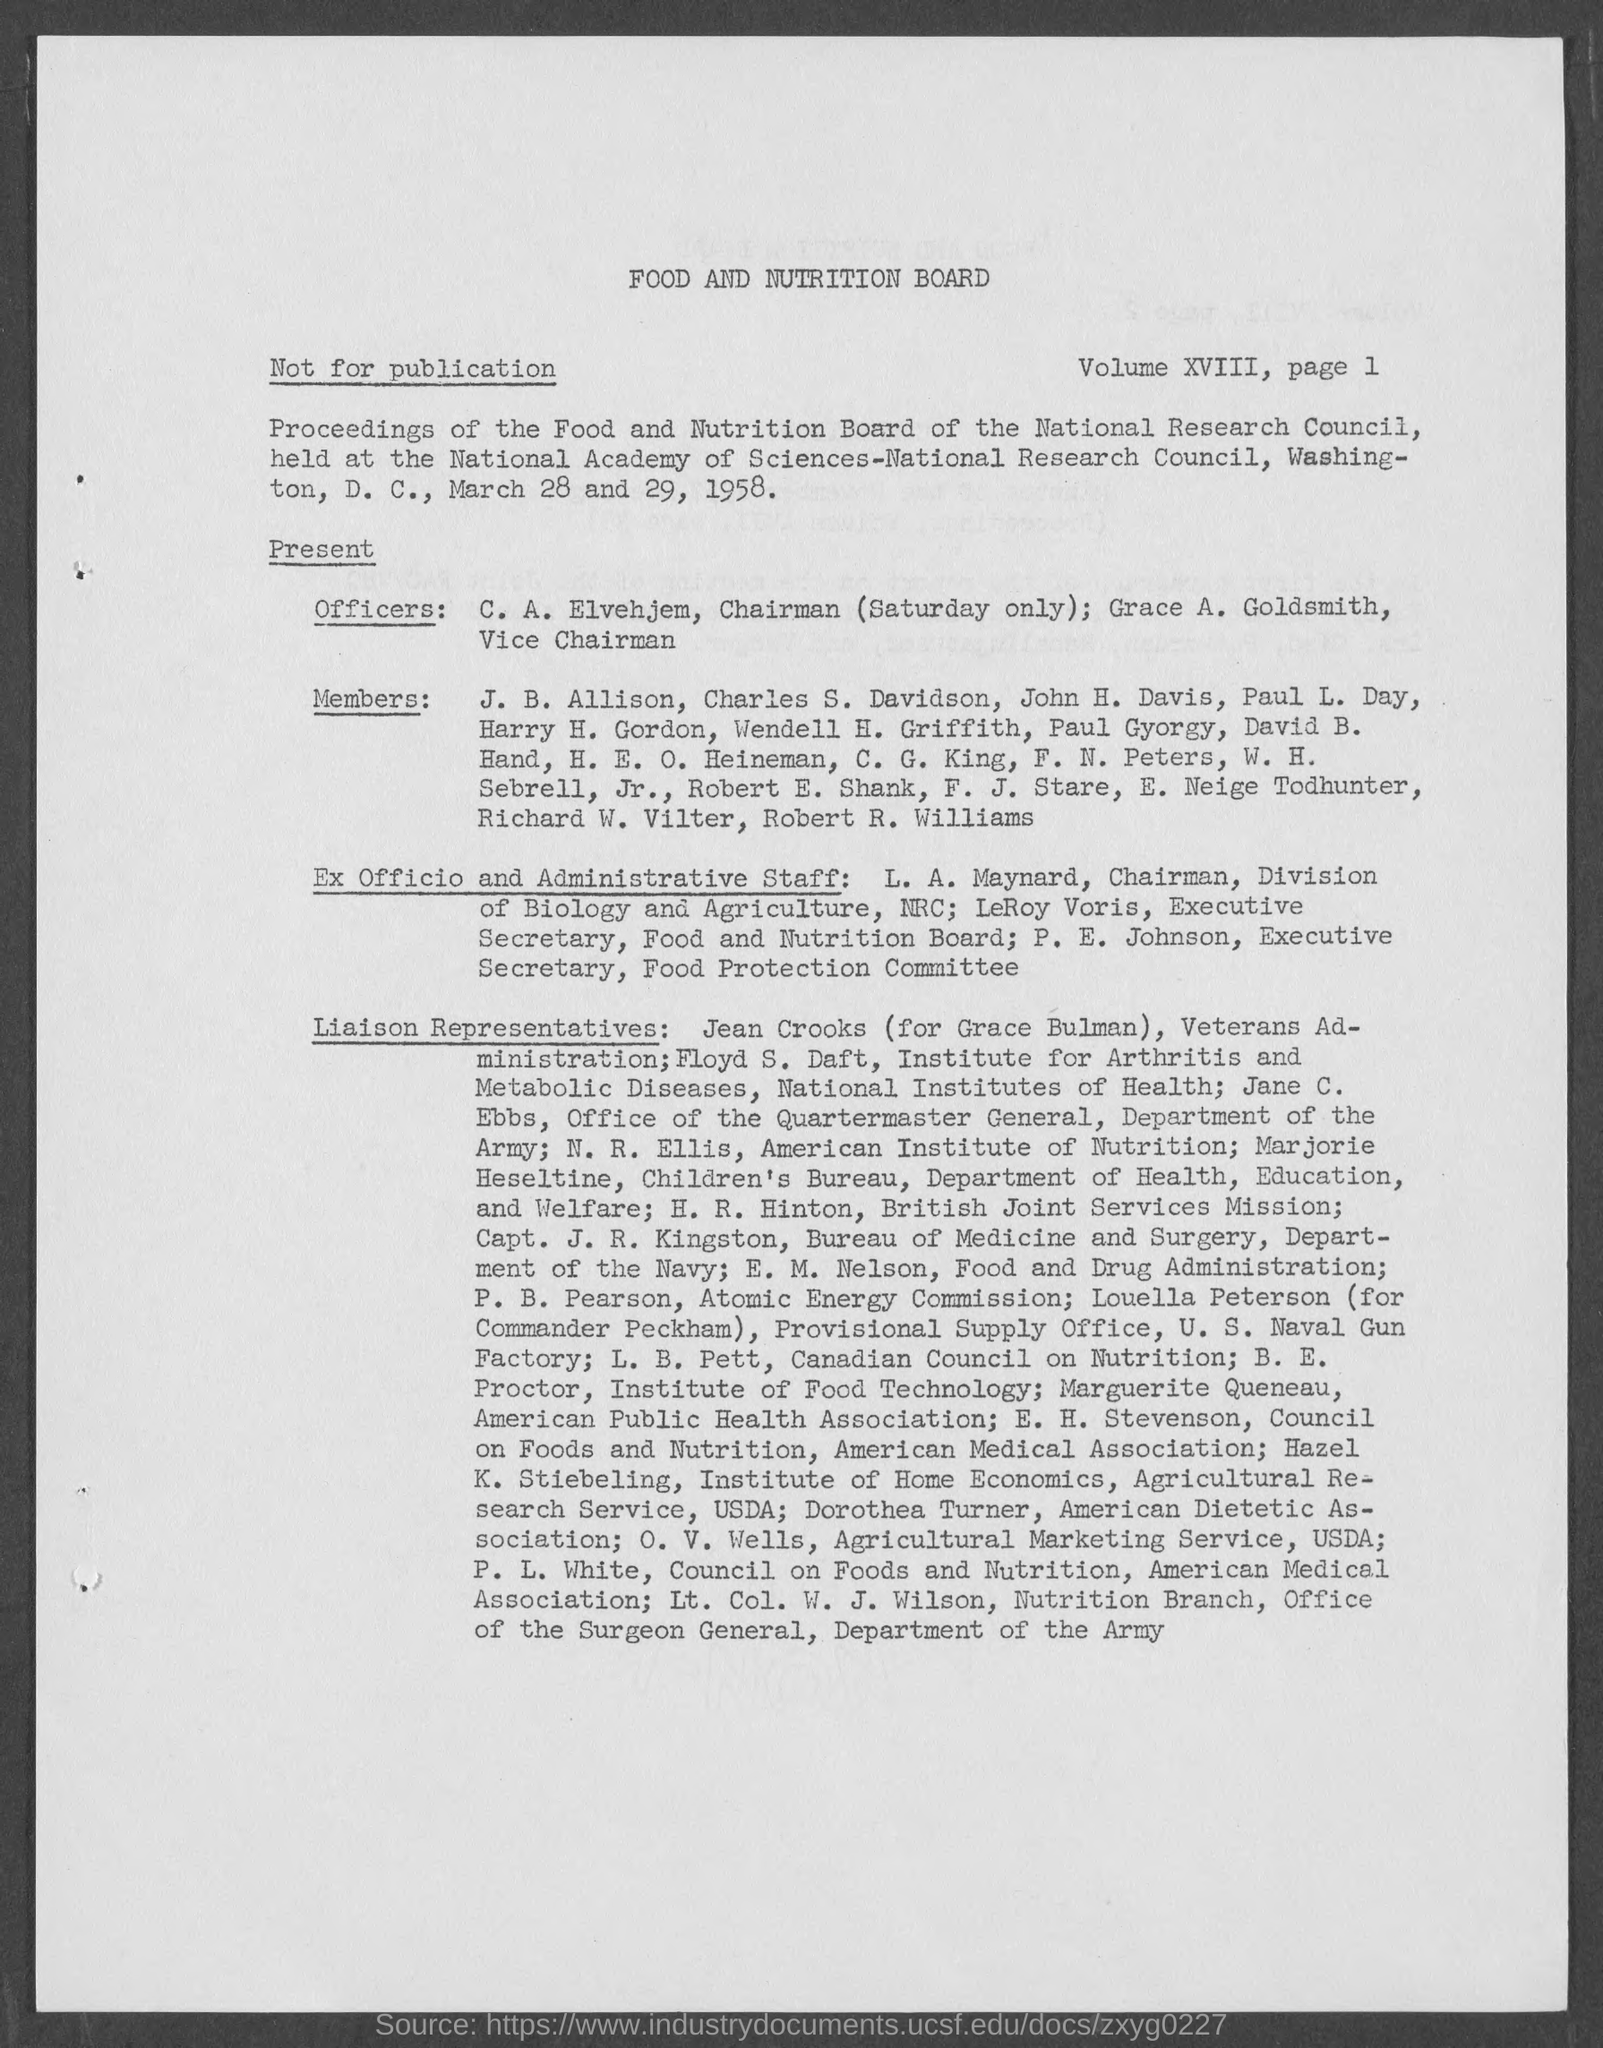What is the heading of the page?
Offer a very short reply. Food and Nutrition Board. 